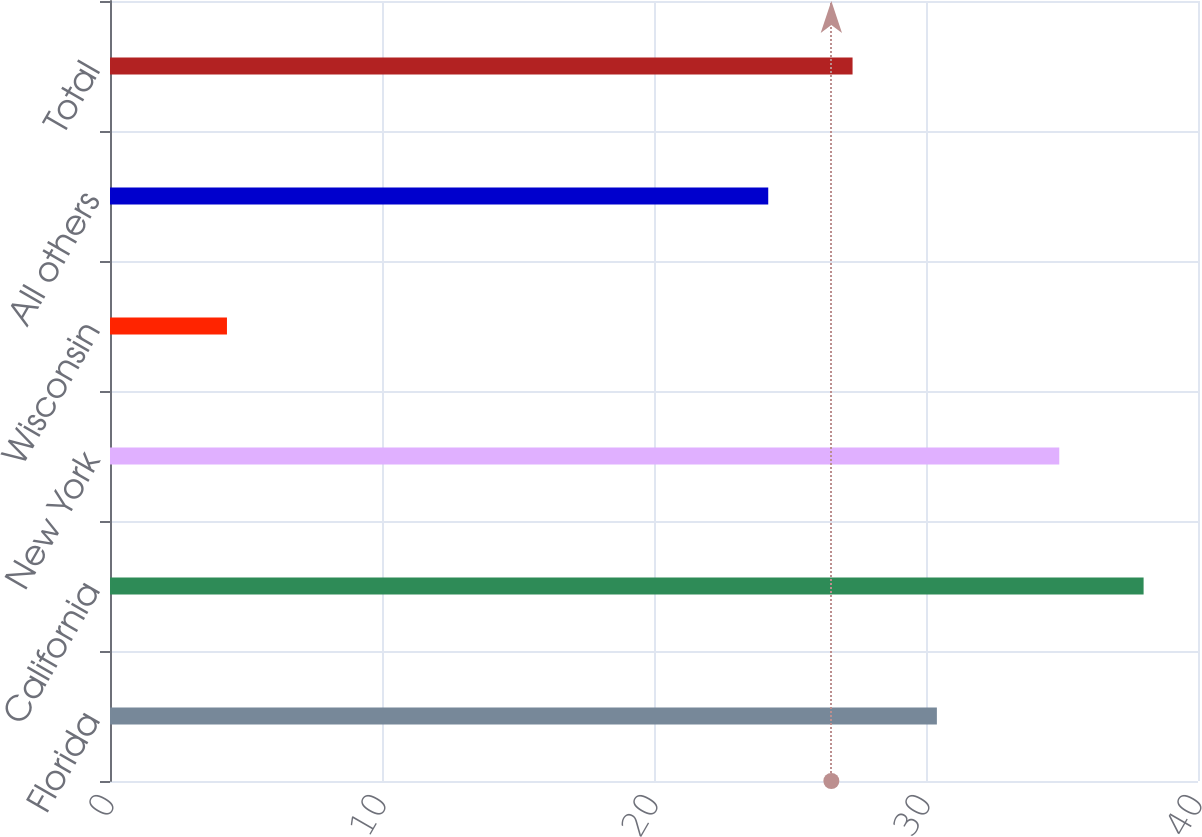<chart> <loc_0><loc_0><loc_500><loc_500><bar_chart><fcel>Florida<fcel>California<fcel>New York<fcel>Wisconsin<fcel>All others<fcel>Total<nl><fcel>30.4<fcel>38<fcel>34.9<fcel>4.3<fcel>24.2<fcel>27.3<nl></chart> 